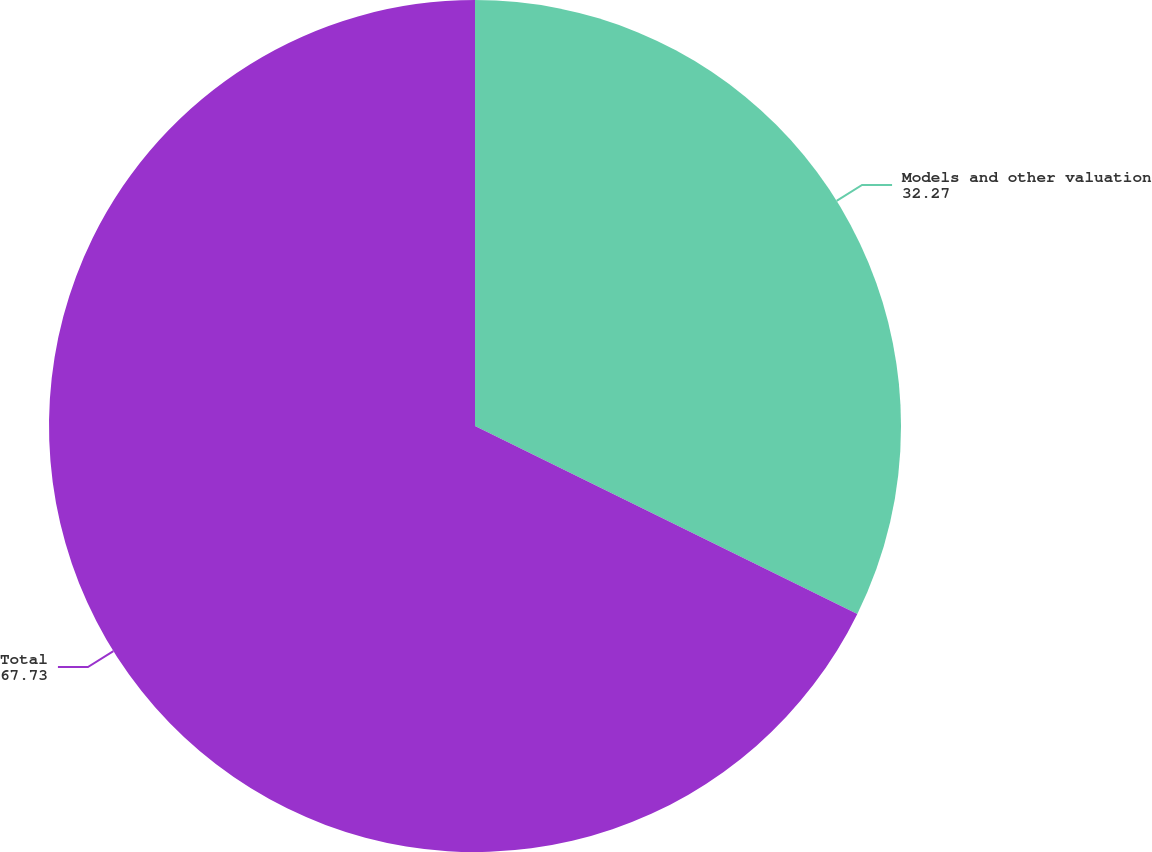<chart> <loc_0><loc_0><loc_500><loc_500><pie_chart><fcel>Models and other valuation<fcel>Total<nl><fcel>32.27%<fcel>67.73%<nl></chart> 